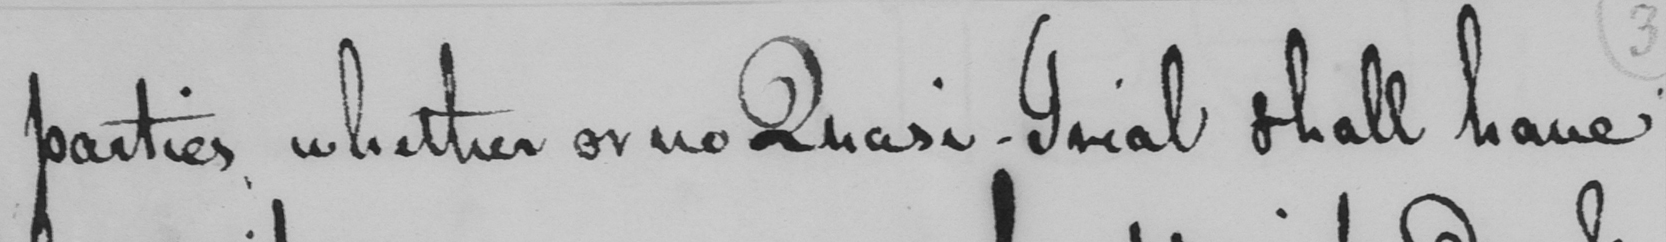Please provide the text content of this handwritten line. parties whether or no Quasi-Trial shall have 